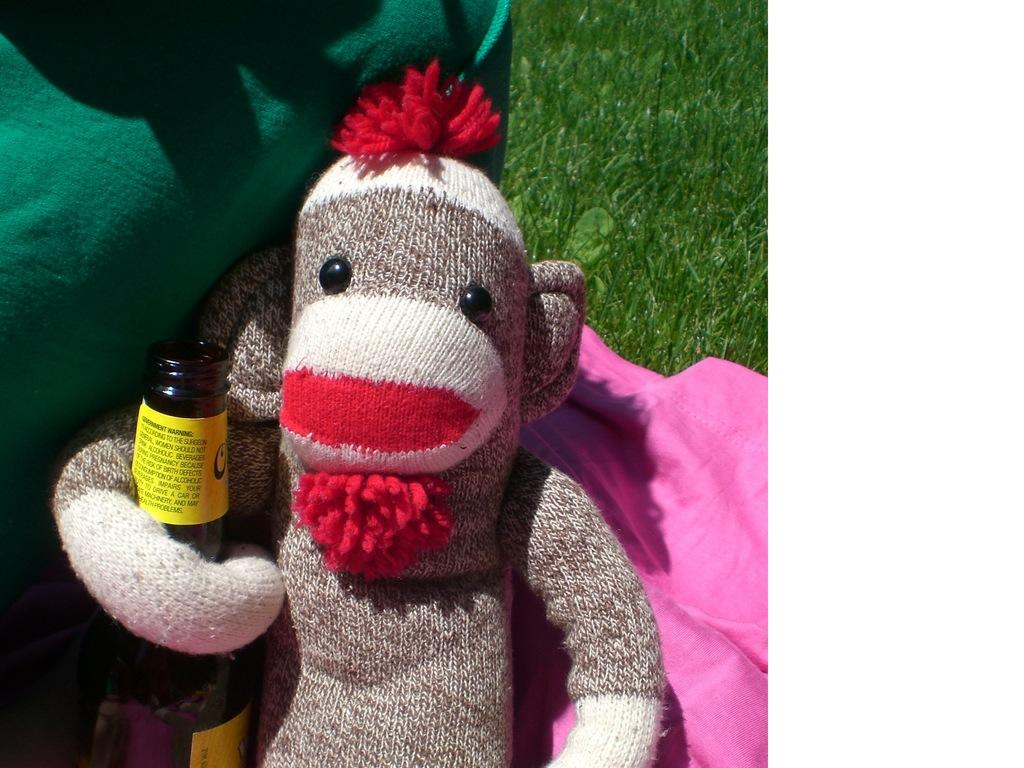What type of toy is present in the image? There is a monkey toy made up of wool in the image. What else can be seen in the image besides the toy? There is a beverage bottle in the image. What type of natural environment is visible in the image? There is grass visible in the image. What type of corn is growing in the image? There is no corn present in the image; it features a monkey toy made up of wool, a beverage bottle, and grass. 